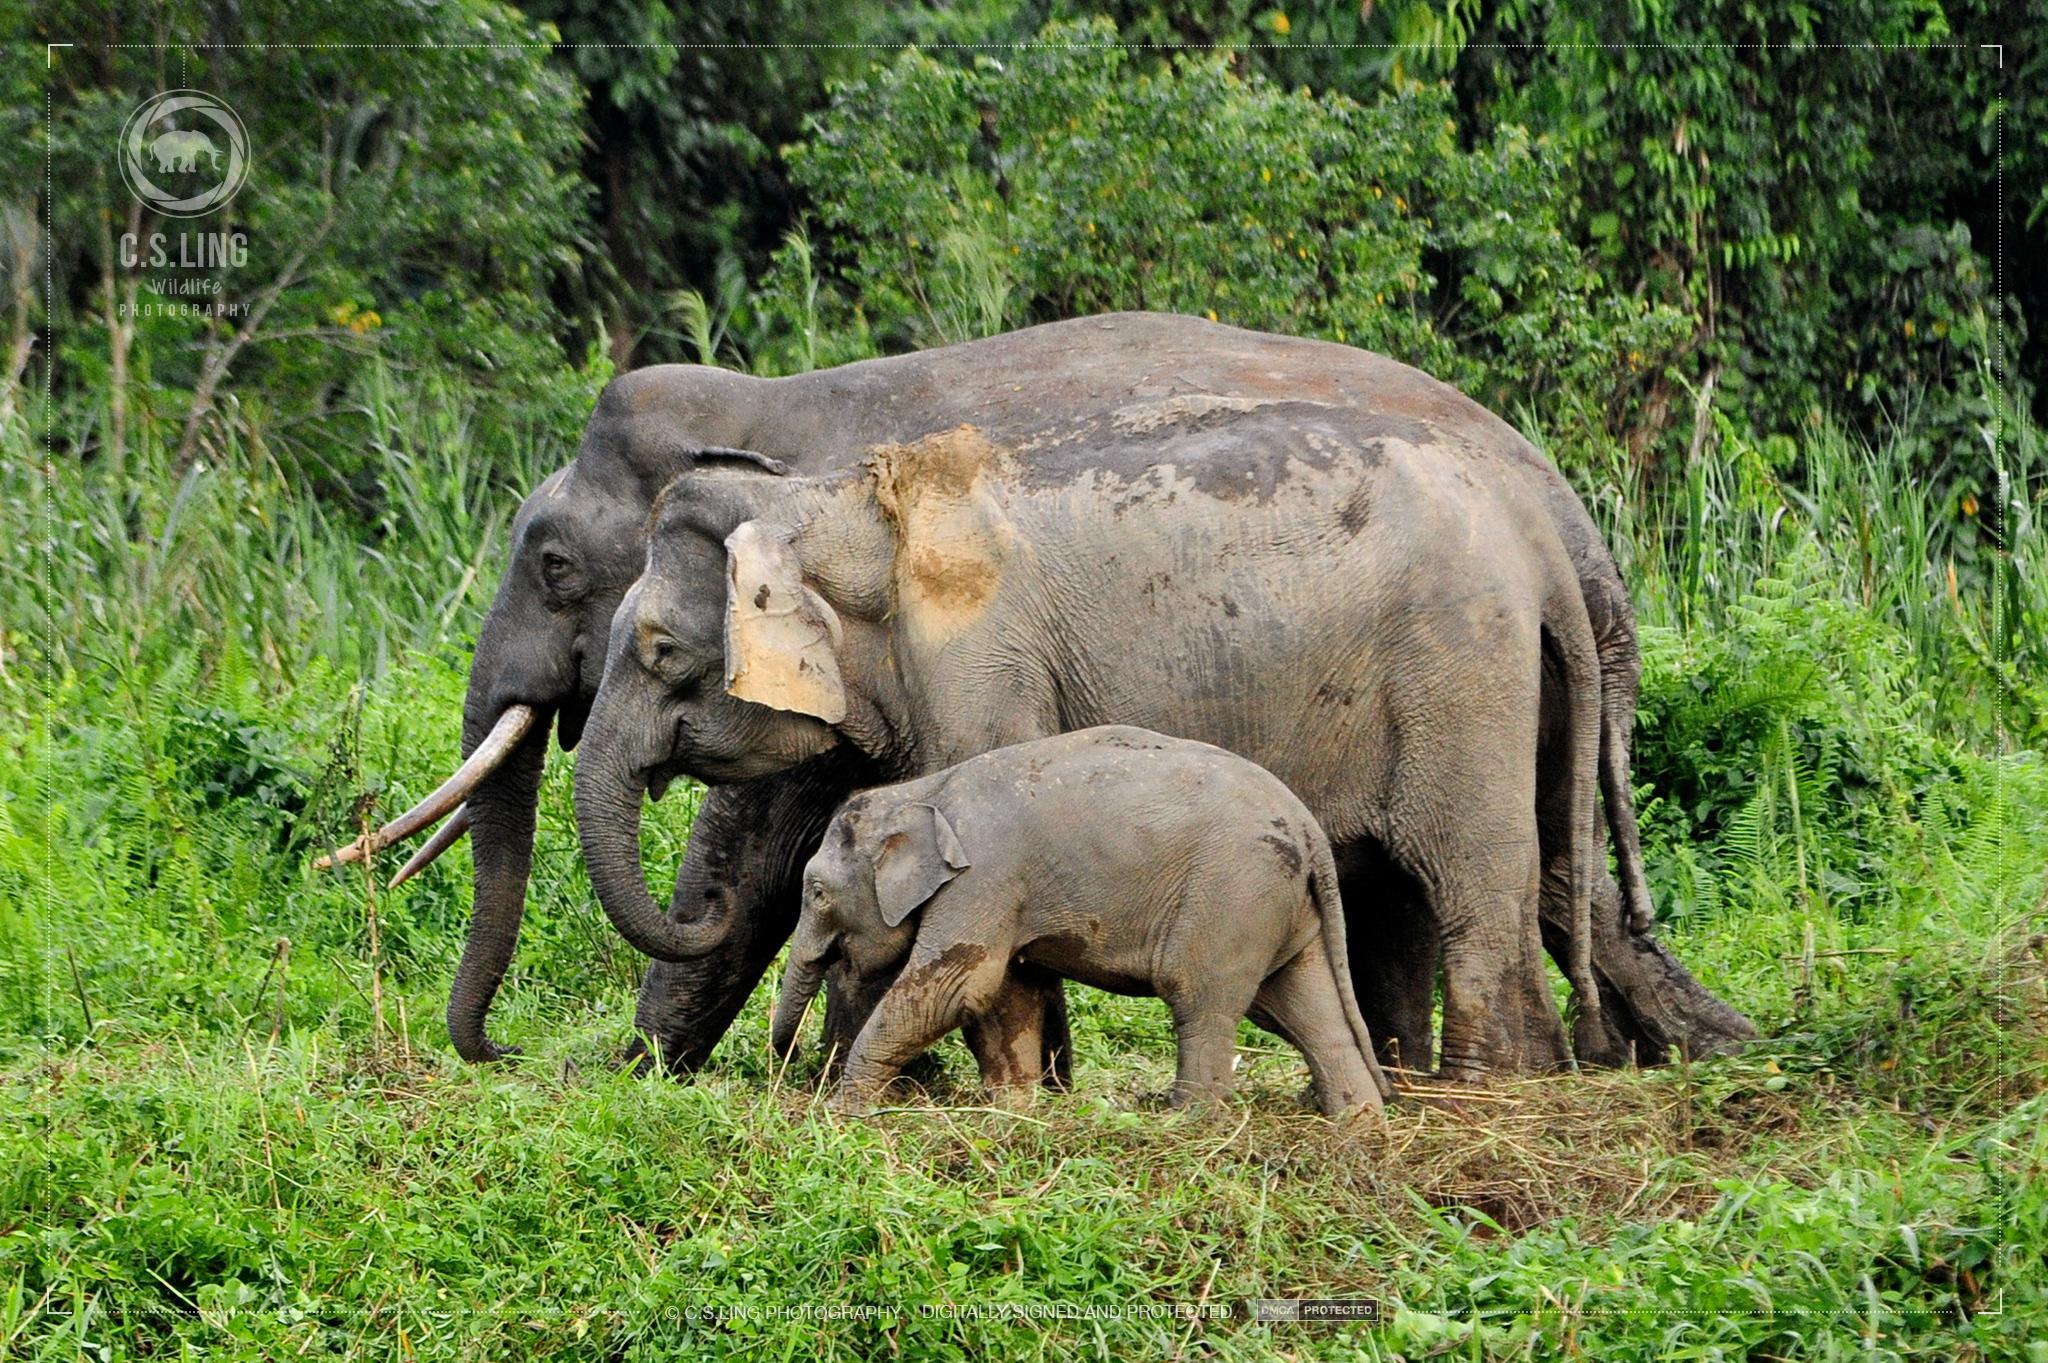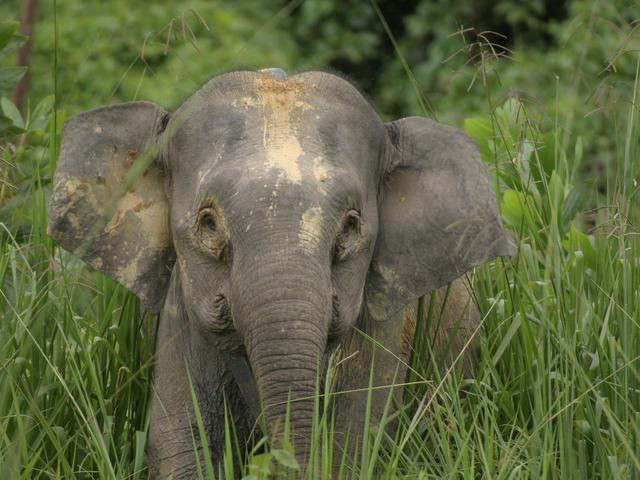The first image is the image on the left, the second image is the image on the right. For the images shown, is this caption "One image has only one elephant in it." true? Answer yes or no. Yes. 